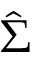<formula> <loc_0><loc_0><loc_500><loc_500>\hat { \Sigma }</formula> 